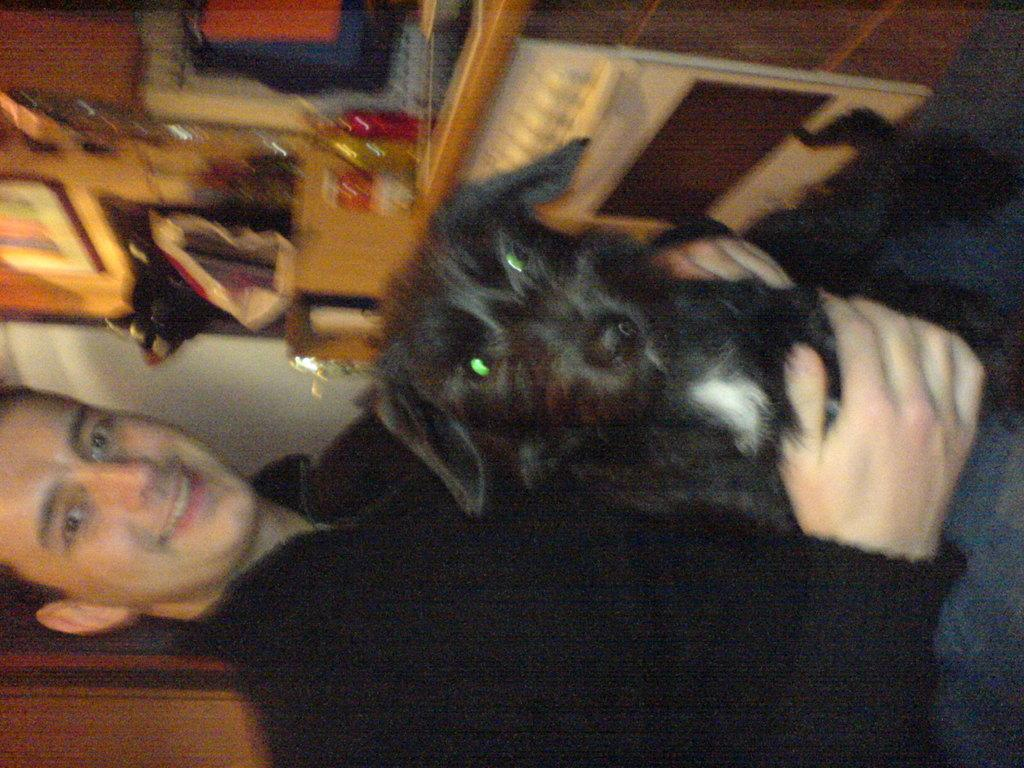Who is present in the image? There is a man in the image. What is the man holding in the image? The man is holding a black color dog. What type of gate is visible in the image? There is no gate present in the image. Is the man's son riding a bike in the image? There is no son or bike present in the image. 